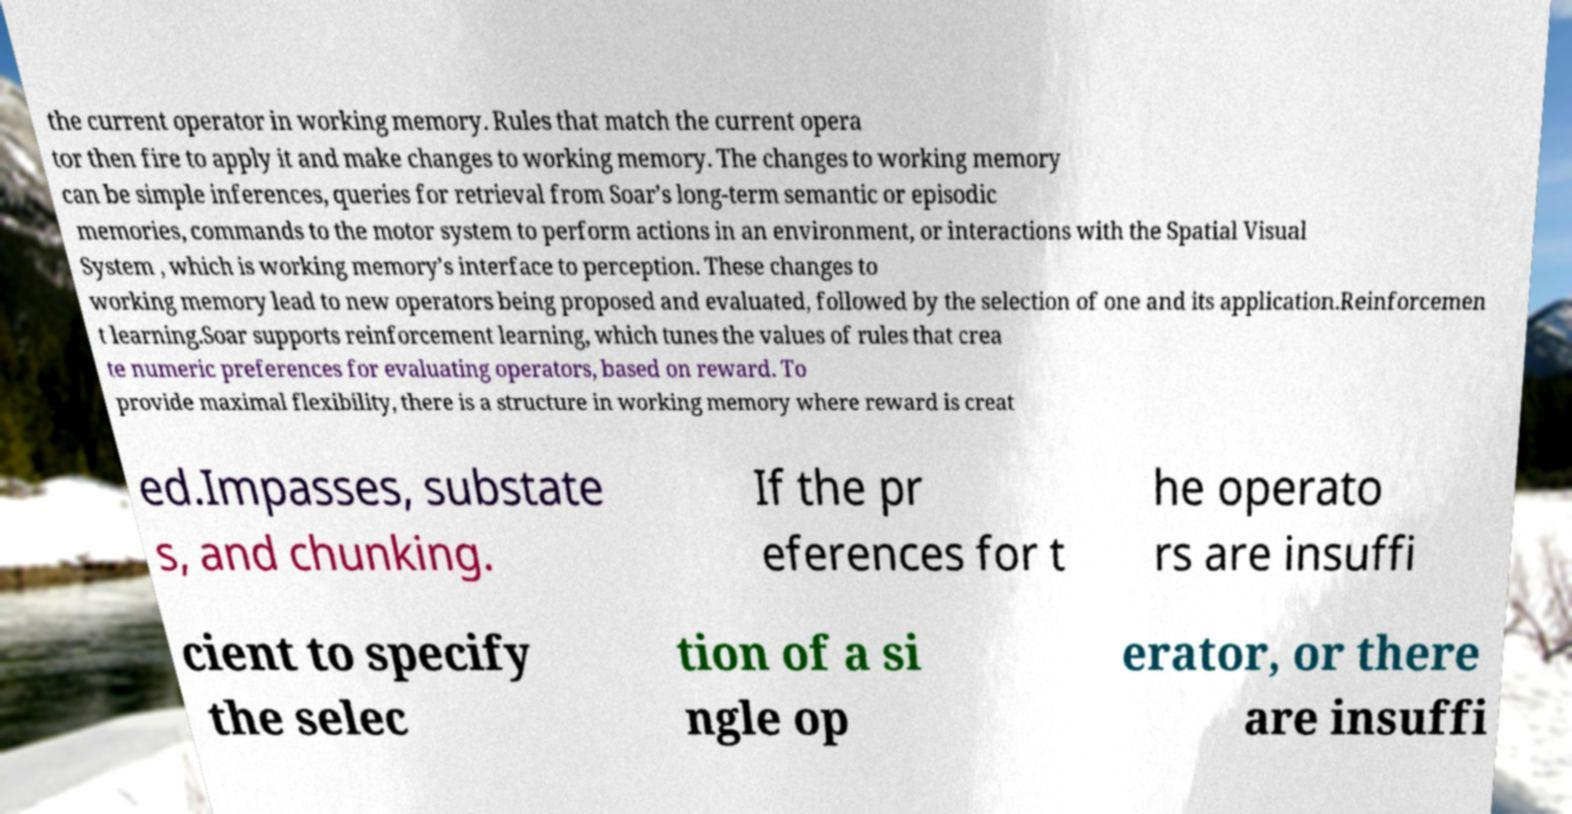I need the written content from this picture converted into text. Can you do that? the current operator in working memory. Rules that match the current opera tor then fire to apply it and make changes to working memory. The changes to working memory can be simple inferences, queries for retrieval from Soar’s long-term semantic or episodic memories, commands to the motor system to perform actions in an environment, or interactions with the Spatial Visual System , which is working memory’s interface to perception. These changes to working memory lead to new operators being proposed and evaluated, followed by the selection of one and its application.Reinforcemen t learning.Soar supports reinforcement learning, which tunes the values of rules that crea te numeric preferences for evaluating operators, based on reward. To provide maximal flexibility, there is a structure in working memory where reward is creat ed.Impasses, substate s, and chunking. If the pr eferences for t he operato rs are insuffi cient to specify the selec tion of a si ngle op erator, or there are insuffi 